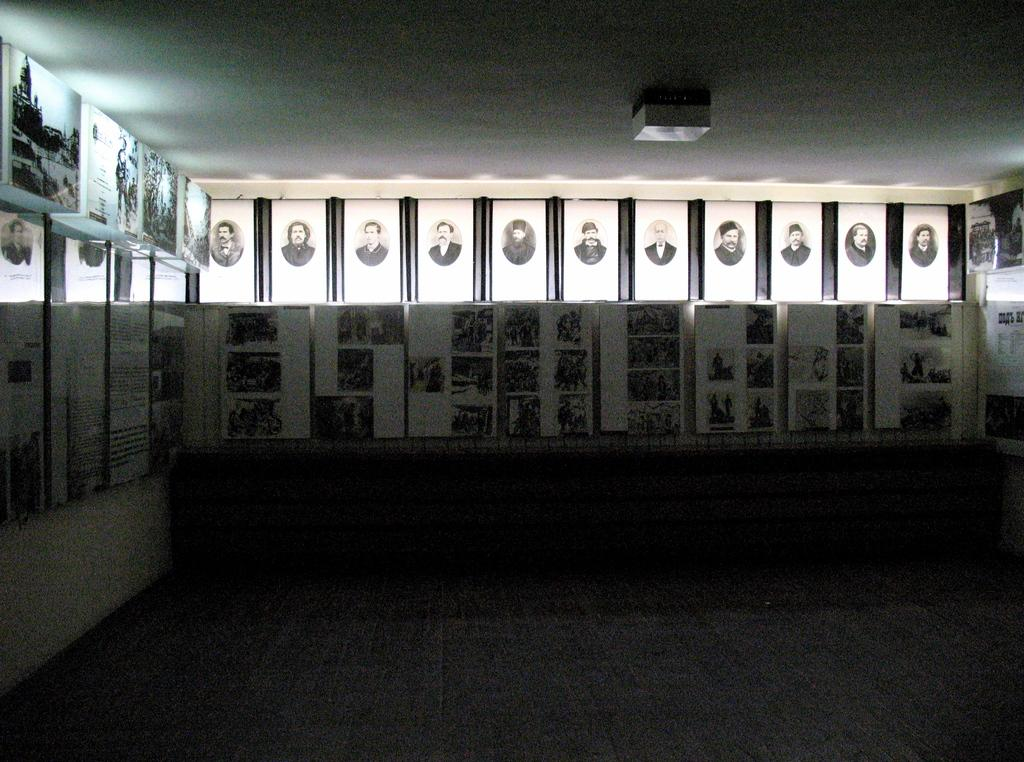What type of location is depicted in the image? The image is an inside view of a room. What can be seen on the walls of the room? There are many photo frames attached to the walls in the room. What type of discovery was made in the room during the recent expedition? There is no mention of an expedition or discovery in the image or the provided facts. 